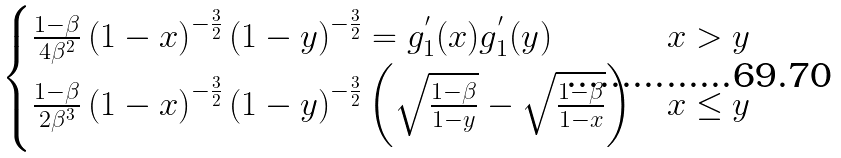Convert formula to latex. <formula><loc_0><loc_0><loc_500><loc_500>\begin{cases} \frac { 1 - \beta } { 4 \beta ^ { 2 } } \left ( 1 - x \right ) ^ { - \frac { 3 } { 2 } } \left ( 1 - y \right ) ^ { - \frac { 3 } { 2 } } = g _ { 1 } ^ { ^ { \prime } } ( x ) g _ { 1 } ^ { ^ { \prime } } ( y ) & x > y \\ \frac { 1 - \beta } { 2 \beta ^ { 3 } } \left ( 1 - x \right ) ^ { - \frac { 3 } { 2 } } \left ( 1 - y \right ) ^ { - \frac { 3 } { 2 } } \left ( \sqrt { \frac { 1 - \beta } { 1 - y } } - \sqrt { \frac { 1 - \beta } { 1 - x } } \right ) & x \leq y \end{cases}</formula> 